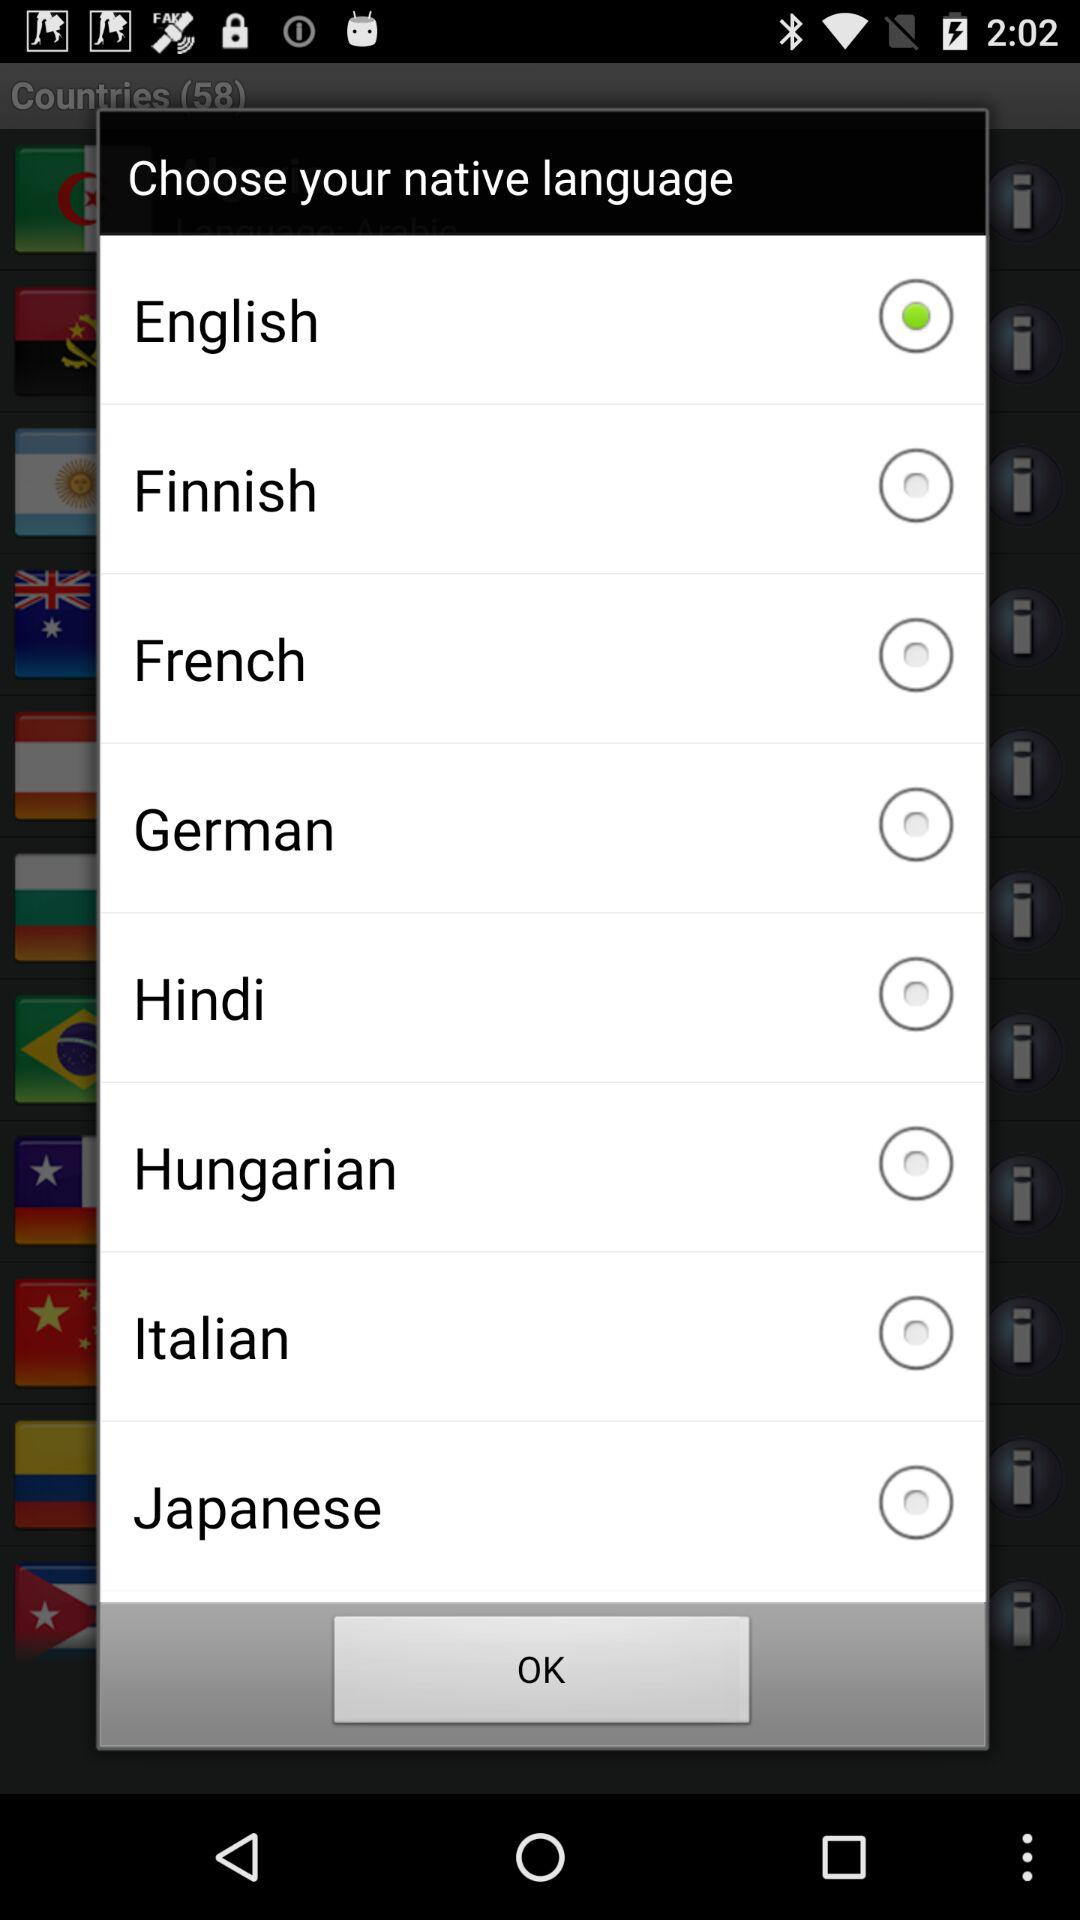Which language is selected? The selected language is English. 